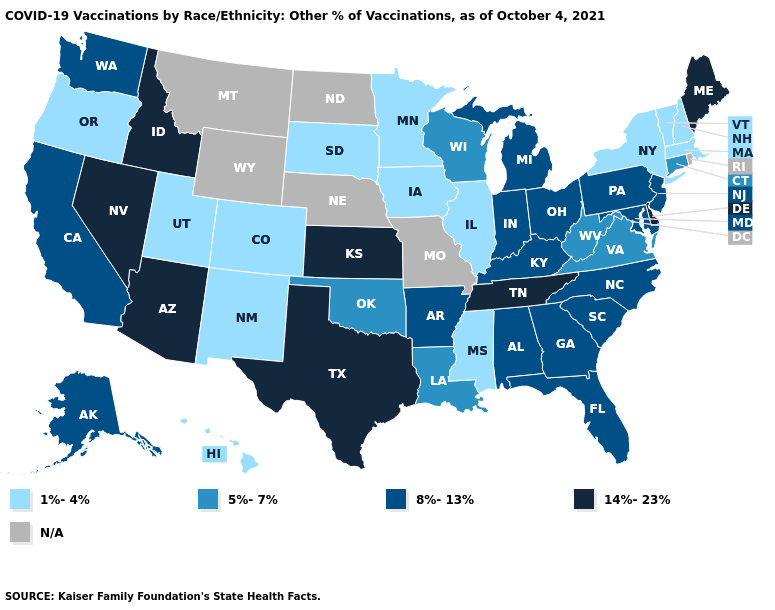Name the states that have a value in the range N/A?
Concise answer only. Missouri, Montana, Nebraska, North Dakota, Rhode Island, Wyoming. Which states have the highest value in the USA?
Be succinct. Arizona, Delaware, Idaho, Kansas, Maine, Nevada, Tennessee, Texas. Name the states that have a value in the range 14%-23%?
Concise answer only. Arizona, Delaware, Idaho, Kansas, Maine, Nevada, Tennessee, Texas. Which states have the lowest value in the USA?
Answer briefly. Colorado, Hawaii, Illinois, Iowa, Massachusetts, Minnesota, Mississippi, New Hampshire, New Mexico, New York, Oregon, South Dakota, Utah, Vermont. Does Michigan have the lowest value in the USA?
Be succinct. No. Which states have the lowest value in the West?
Concise answer only. Colorado, Hawaii, New Mexico, Oregon, Utah. Does Pennsylvania have the lowest value in the USA?
Answer briefly. No. Which states have the highest value in the USA?
Quick response, please. Arizona, Delaware, Idaho, Kansas, Maine, Nevada, Tennessee, Texas. How many symbols are there in the legend?
Concise answer only. 5. Name the states that have a value in the range 8%-13%?
Short answer required. Alabama, Alaska, Arkansas, California, Florida, Georgia, Indiana, Kentucky, Maryland, Michigan, New Jersey, North Carolina, Ohio, Pennsylvania, South Carolina, Washington. Which states hav the highest value in the South?
Short answer required. Delaware, Tennessee, Texas. Name the states that have a value in the range 8%-13%?
Be succinct. Alabama, Alaska, Arkansas, California, Florida, Georgia, Indiana, Kentucky, Maryland, Michigan, New Jersey, North Carolina, Ohio, Pennsylvania, South Carolina, Washington. Does Nevada have the highest value in the USA?
Give a very brief answer. Yes. 